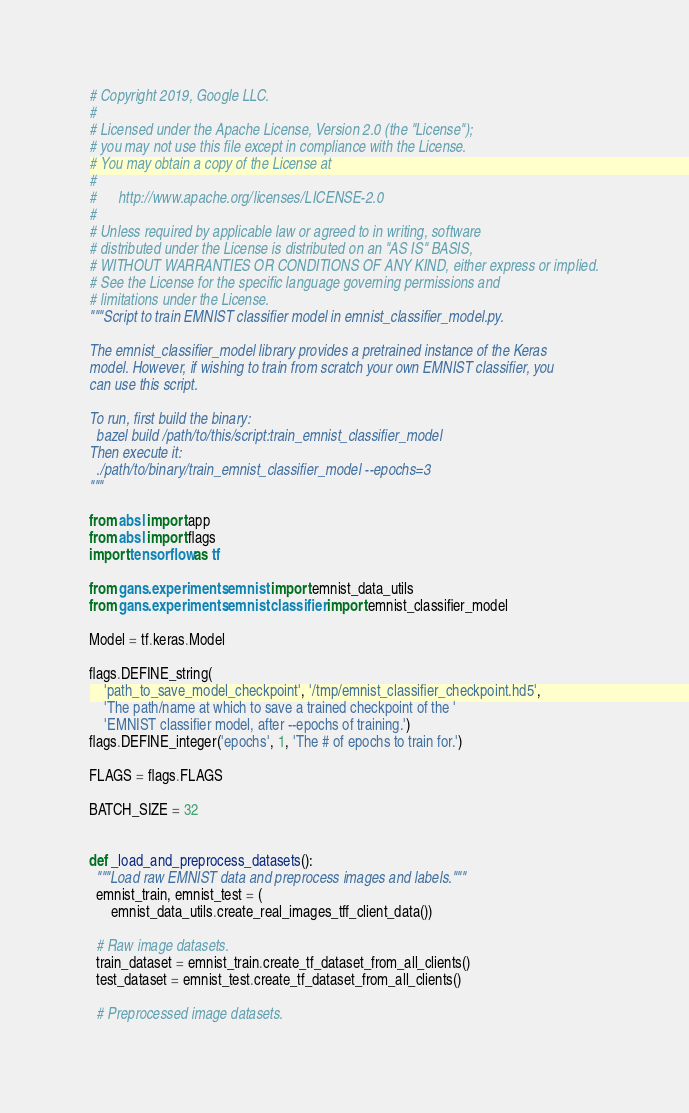<code> <loc_0><loc_0><loc_500><loc_500><_Python_># Copyright 2019, Google LLC.
#
# Licensed under the Apache License, Version 2.0 (the "License");
# you may not use this file except in compliance with the License.
# You may obtain a copy of the License at
#
#      http://www.apache.org/licenses/LICENSE-2.0
#
# Unless required by applicable law or agreed to in writing, software
# distributed under the License is distributed on an "AS IS" BASIS,
# WITHOUT WARRANTIES OR CONDITIONS OF ANY KIND, either express or implied.
# See the License for the specific language governing permissions and
# limitations under the License.
"""Script to train EMNIST classifier model in emnist_classifier_model.py.

The emnist_classifier_model library provides a pretrained instance of the Keras
model. However, if wishing to train from scratch your own EMNIST classifier, you
can use this script.

To run, first build the binary:
  bazel build /path/to/this/script:train_emnist_classifier_model
Then execute it:
  ./path/to/binary/train_emnist_classifier_model --epochs=3
"""

from absl import app
from absl import flags
import tensorflow as tf

from gans.experiments.emnist import emnist_data_utils
from gans.experiments.emnist.classifier import emnist_classifier_model

Model = tf.keras.Model

flags.DEFINE_string(
    'path_to_save_model_checkpoint', '/tmp/emnist_classifier_checkpoint.hd5',
    'The path/name at which to save a trained checkpoint of the '
    'EMNIST classifier model, after --epochs of training.')
flags.DEFINE_integer('epochs', 1, 'The # of epochs to train for.')

FLAGS = flags.FLAGS

BATCH_SIZE = 32


def _load_and_preprocess_datasets():
  """Load raw EMNIST data and preprocess images and labels."""
  emnist_train, emnist_test = (
      emnist_data_utils.create_real_images_tff_client_data())

  # Raw image datasets.
  train_dataset = emnist_train.create_tf_dataset_from_all_clients()
  test_dataset = emnist_test.create_tf_dataset_from_all_clients()

  # Preprocessed image datasets.</code> 